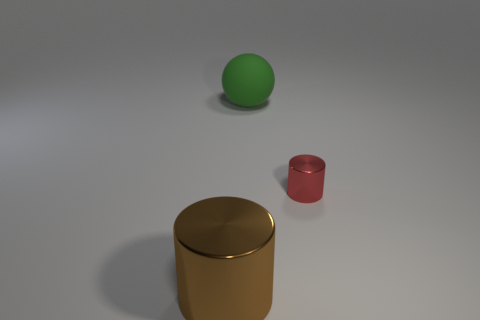Are there any textures or materials on these objects that stand out to you? Yes, each object has a distinct texture and material finish. The large cylinder has a matte, slightly rough finish, making it non-reflective. The small red cylinder seems to have a satin finish with a slight sheen. The green sphere, however, has a somewhat plastic look with a smooth surface, and the gold object has a reflective metal finish. 